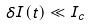Convert formula to latex. <formula><loc_0><loc_0><loc_500><loc_500>\delta I ( t ) \ll I _ { c }</formula> 